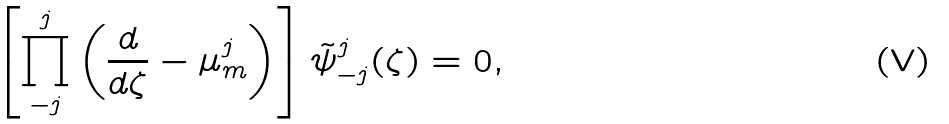<formula> <loc_0><loc_0><loc_500><loc_500>\left [ \prod _ { - j } ^ { j } \left ( \frac { d } { d \zeta } - \mu ^ { j } _ { m } \right ) \right ] \tilde { \psi } ^ { j } _ { - j } ( \zeta ) = 0 ,</formula> 